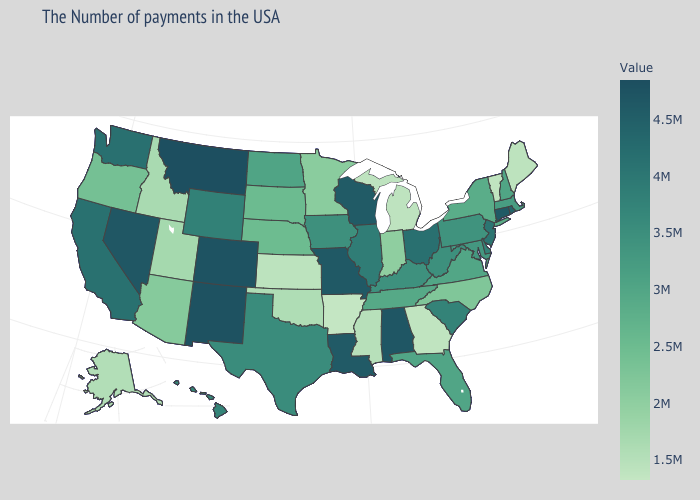Is the legend a continuous bar?
Concise answer only. Yes. Which states have the highest value in the USA?
Short answer required. Montana. Among the states that border Wisconsin , which have the highest value?
Quick response, please. Illinois. Does Alaska have the highest value in the USA?
Be succinct. No. Does Vermont have the lowest value in the Northeast?
Give a very brief answer. Yes. Does the map have missing data?
Short answer required. No. Among the states that border Massachusetts , does New York have the lowest value?
Write a very short answer. No. 